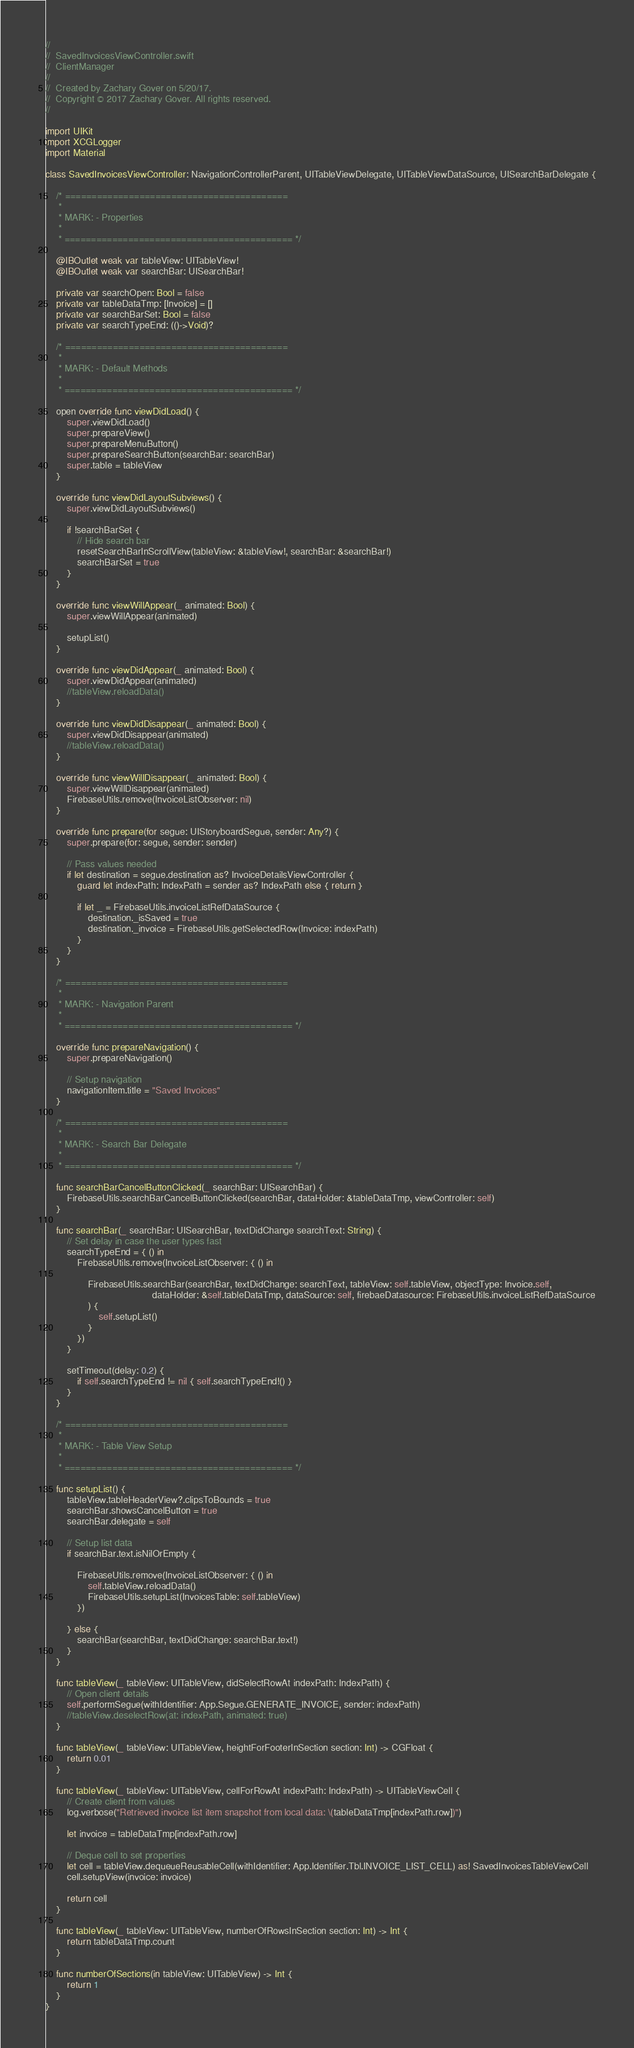<code> <loc_0><loc_0><loc_500><loc_500><_Swift_>//
//  SavedInvoicesViewController.swift
//  ClientManager
//
//  Created by Zachary Gover on 5/20/17.
//  Copyright © 2017 Zachary Gover. All rights reserved.
//

import UIKit
import XCGLogger
import Material

class SavedInvoicesViewController: NavigationControllerParent, UITableViewDelegate, UITableViewDataSource, UISearchBarDelegate {

    /* ==========================================
     *
     * MARK: - Properties
     *
     * =========================================== */
    
    @IBOutlet weak var tableView: UITableView!
    @IBOutlet weak var searchBar: UISearchBar!

    private var searchOpen: Bool = false
    private var tableDataTmp: [Invoice] = []
    private var searchBarSet: Bool = false
    private var searchTypeEnd: (()->Void)?

    /* ==========================================
     *
     * MARK: - Default Methods
     *
     * =========================================== */

    open override func viewDidLoad() {
        super.viewDidLoad()
        super.prepareView()
        super.prepareMenuButton()
        super.prepareSearchButton(searchBar: searchBar)
        super.table = tableView
    }

    override func viewDidLayoutSubviews() {
        super.viewDidLayoutSubviews()

        if !searchBarSet {
            // Hide search bar
            resetSearchBarInScrollView(tableView: &tableView!, searchBar: &searchBar!)
            searchBarSet = true
        }
    }

    override func viewWillAppear(_ animated: Bool) {
        super.viewWillAppear(animated)

        setupList()
    }

    override func viewDidAppear(_ animated: Bool) {
        super.viewDidAppear(animated)
        //tableView.reloadData()
    }

    override func viewDidDisappear(_ animated: Bool) {
        super.viewDidDisappear(animated)
        //tableView.reloadData()
    }

    override func viewWillDisappear(_ animated: Bool) {
        super.viewWillDisappear(animated)
        FirebaseUtils.remove(InvoiceListObserver: nil)
    }

    override func prepare(for segue: UIStoryboardSegue, sender: Any?) {
        super.prepare(for: segue, sender: sender)

        // Pass values needed
        if let destination = segue.destination as? InvoiceDetailsViewController {
            guard let indexPath: IndexPath = sender as? IndexPath else { return }

            if let _ = FirebaseUtils.invoiceListRefDataSource {
                destination._isSaved = true
                destination._invoice = FirebaseUtils.getSelectedRow(Invoice: indexPath)
            }
        }
    }

    /* ==========================================
     *
     * MARK: - Navigation Parent
     *
     * =========================================== */

    override func prepareNavigation() {
        super.prepareNavigation()

        // Setup navigation
        navigationItem.title = "Saved Invoices"
    }

    /* ==========================================
     *
     * MARK: - Search Bar Delegate
     *
     * =========================================== */

    func searchBarCancelButtonClicked(_ searchBar: UISearchBar) {
        FirebaseUtils.searchBarCancelButtonClicked(searchBar, dataHolder: &tableDataTmp, viewController: self)
    }

    func searchBar(_ searchBar: UISearchBar, textDidChange searchText: String) {
        // Set delay in case the user types fast
        searchTypeEnd = { () in
            FirebaseUtils.remove(InvoiceListObserver: { () in

                FirebaseUtils.searchBar(searchBar, textDidChange: searchText, tableView: self.tableView, objectType: Invoice.self,
                                        dataHolder: &self.tableDataTmp, dataSource: self, firebaeDatasource: FirebaseUtils.invoiceListRefDataSource
                ) {
                    self.setupList()
                }
            })
        }

        setTimeout(delay: 0.2) {
            if self.searchTypeEnd != nil { self.searchTypeEnd!() }
        }
    }

    /* ==========================================
     *
     * MARK: - Table View Setup
     *
     * =========================================== */

    func setupList() {
        tableView.tableHeaderView?.clipsToBounds = true
        searchBar.showsCancelButton = true
        searchBar.delegate = self

        // Setup list data
        if searchBar.text.isNilOrEmpty {

            FirebaseUtils.remove(InvoiceListObserver: { () in
                self.tableView.reloadData()
                FirebaseUtils.setupList(InvoicesTable: self.tableView)
            })

        } else {
            searchBar(searchBar, textDidChange: searchBar.text!)
        }
    }

    func tableView(_ tableView: UITableView, didSelectRowAt indexPath: IndexPath) {
        // Open client details
        self.performSegue(withIdentifier: App.Segue.GENERATE_INVOICE, sender: indexPath)
        //tableView.deselectRow(at: indexPath, animated: true)
    }

    func tableView(_ tableView: UITableView, heightForFooterInSection section: Int) -> CGFloat {
        return 0.01
    }

    func tableView(_ tableView: UITableView, cellForRowAt indexPath: IndexPath) -> UITableViewCell {
        // Create client from values
        log.verbose("Retrieved invoice list item snapshot from local data: \(tableDataTmp[indexPath.row])")

        let invoice = tableDataTmp[indexPath.row]

        // Deque cell to set properties
        let cell = tableView.dequeueReusableCell(withIdentifier: App.Identifier.Tbl.INVOICE_LIST_CELL) as! SavedInvoicesTableViewCell
        cell.setupView(invoice: invoice)

        return cell
    }

    func tableView(_ tableView: UITableView, numberOfRowsInSection section: Int) -> Int {
        return tableDataTmp.count
    }

    func numberOfSections(in tableView: UITableView) -> Int {
        return 1
    }
}
</code> 